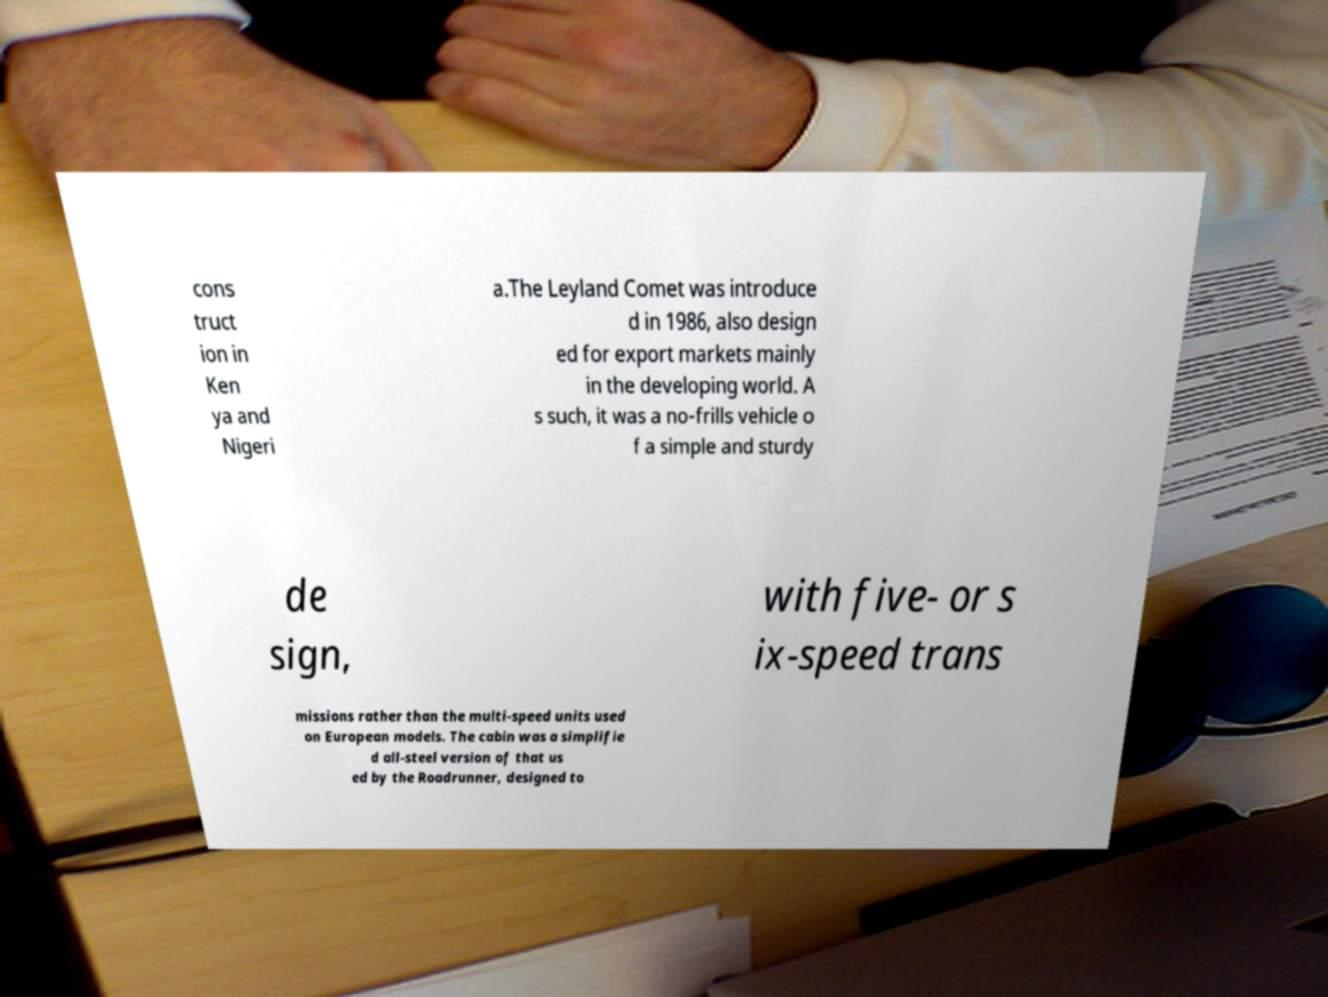Can you read and provide the text displayed in the image?This photo seems to have some interesting text. Can you extract and type it out for me? cons truct ion in Ken ya and Nigeri a.The Leyland Comet was introduce d in 1986, also design ed for export markets mainly in the developing world. A s such, it was a no-frills vehicle o f a simple and sturdy de sign, with five- or s ix-speed trans missions rather than the multi-speed units used on European models. The cabin was a simplifie d all-steel version of that us ed by the Roadrunner, designed to 